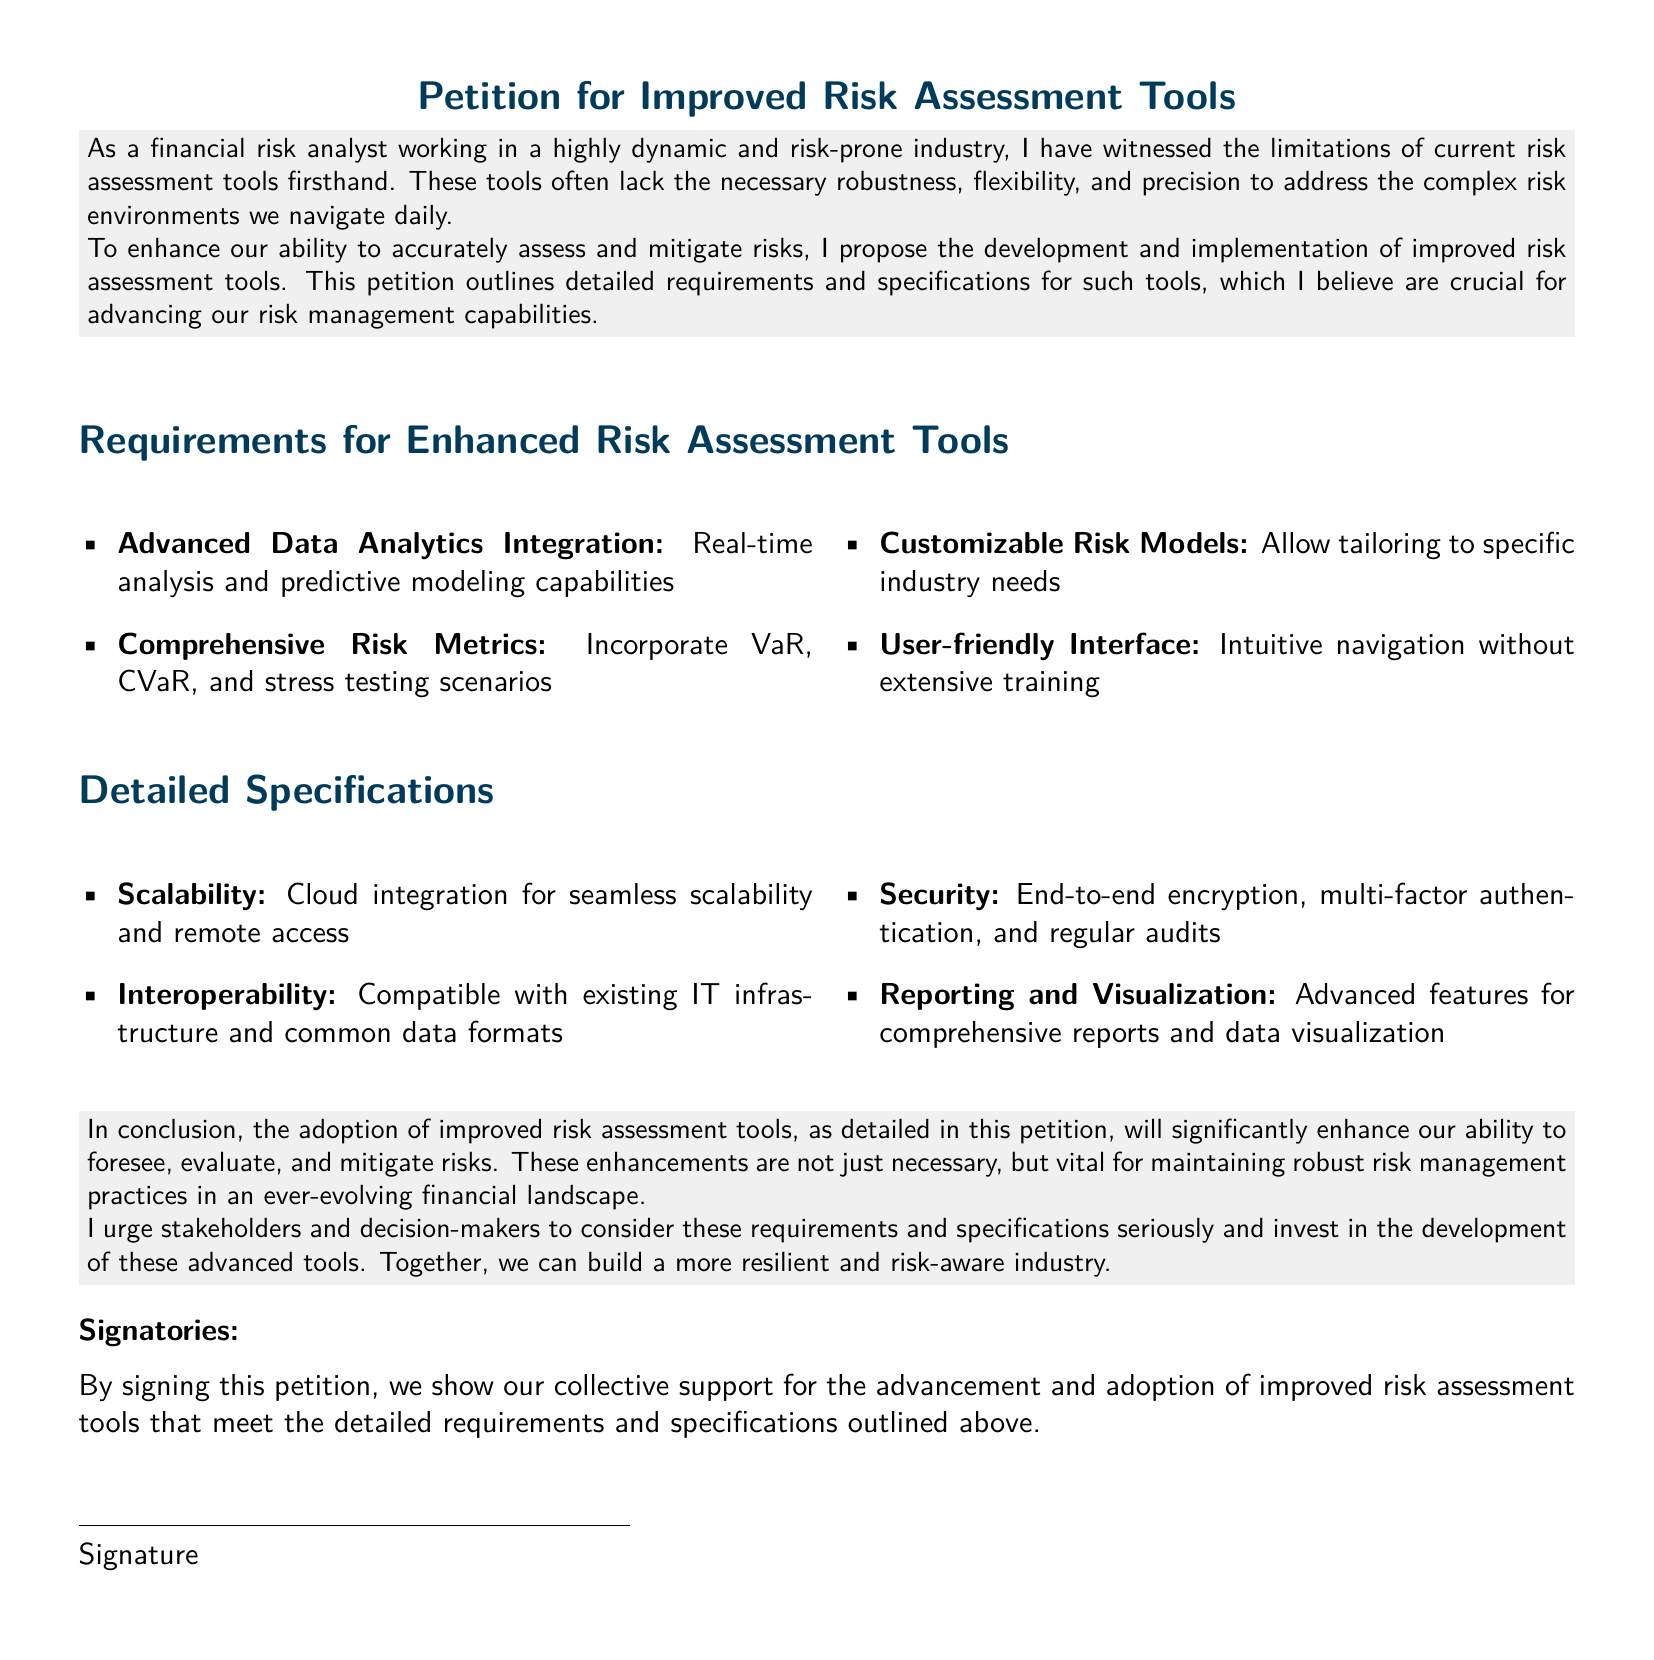what is the title of the petition? The title is prominently displayed at the top of the document and reads "Petition for Improved Risk Assessment Tools."
Answer: Petition for Improved Risk Assessment Tools how many main requirements for enhanced risk assessment tools are listed? There are four main requirements outlined in the petition under the "Requirements for Enhanced Risk Assessment Tools" section.
Answer: 4 what is one of the advanced data analytics integration features proposed? The petition specifies "Real-time analysis and predictive modeling capabilities" as part of the advanced data analytics integration features.
Answer: Real-time analysis and predictive modeling capabilities what is the purpose of this petition? The purpose is outlined in the opening paragraph, which states that improved tools are necessary for enhancing risk assessment and mitigation abilities.
Answer: To enhance risk assessment and mitigation abilities what type of security features are required for the new tools? The specifications mention "End-to-end encryption, multi-factor authentication, and regular audits" as security features required.
Answer: End-to-end encryption, multi-factor authentication, and regular audits who is the intended audience for this petition? The petition urges "stakeholders and decision-makers" to consider the proposed requirements and specifications.
Answer: Stakeholders and decision-makers what is one benefit mentioned of adopting improved risk assessment tools? The petition states that such tools will significantly enhance the ability to "foresee, evaluate, and mitigate risks."
Answer: Enhance ability to foresee, evaluate, and mitigate risks what is the formatting style of sections in the document? The sections are formatted using a color scheme that highlights the section titles in blue.
Answer: Highlighted in blue how can signatories express their support for the petition? Signatories show their support by providing their signatures at the bottom of the document.
Answer: By signing the petition 